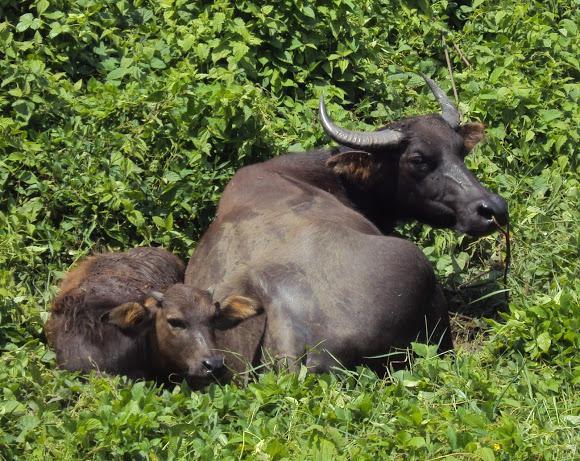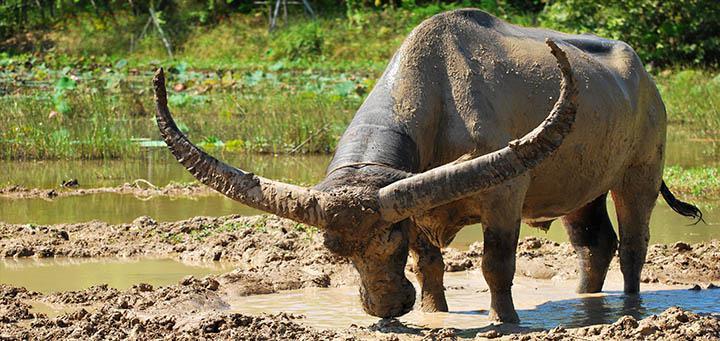The first image is the image on the left, the second image is the image on the right. Examine the images to the left and right. Is the description "One image features one horned animal standing in muddy water with its body turned leftward, and the other image features multiple hooved animals surrounded by greenery." accurate? Answer yes or no. Yes. The first image is the image on the left, the second image is the image on the right. Given the left and right images, does the statement "The cow in the image on the left is walking through the water." hold true? Answer yes or no. No. 